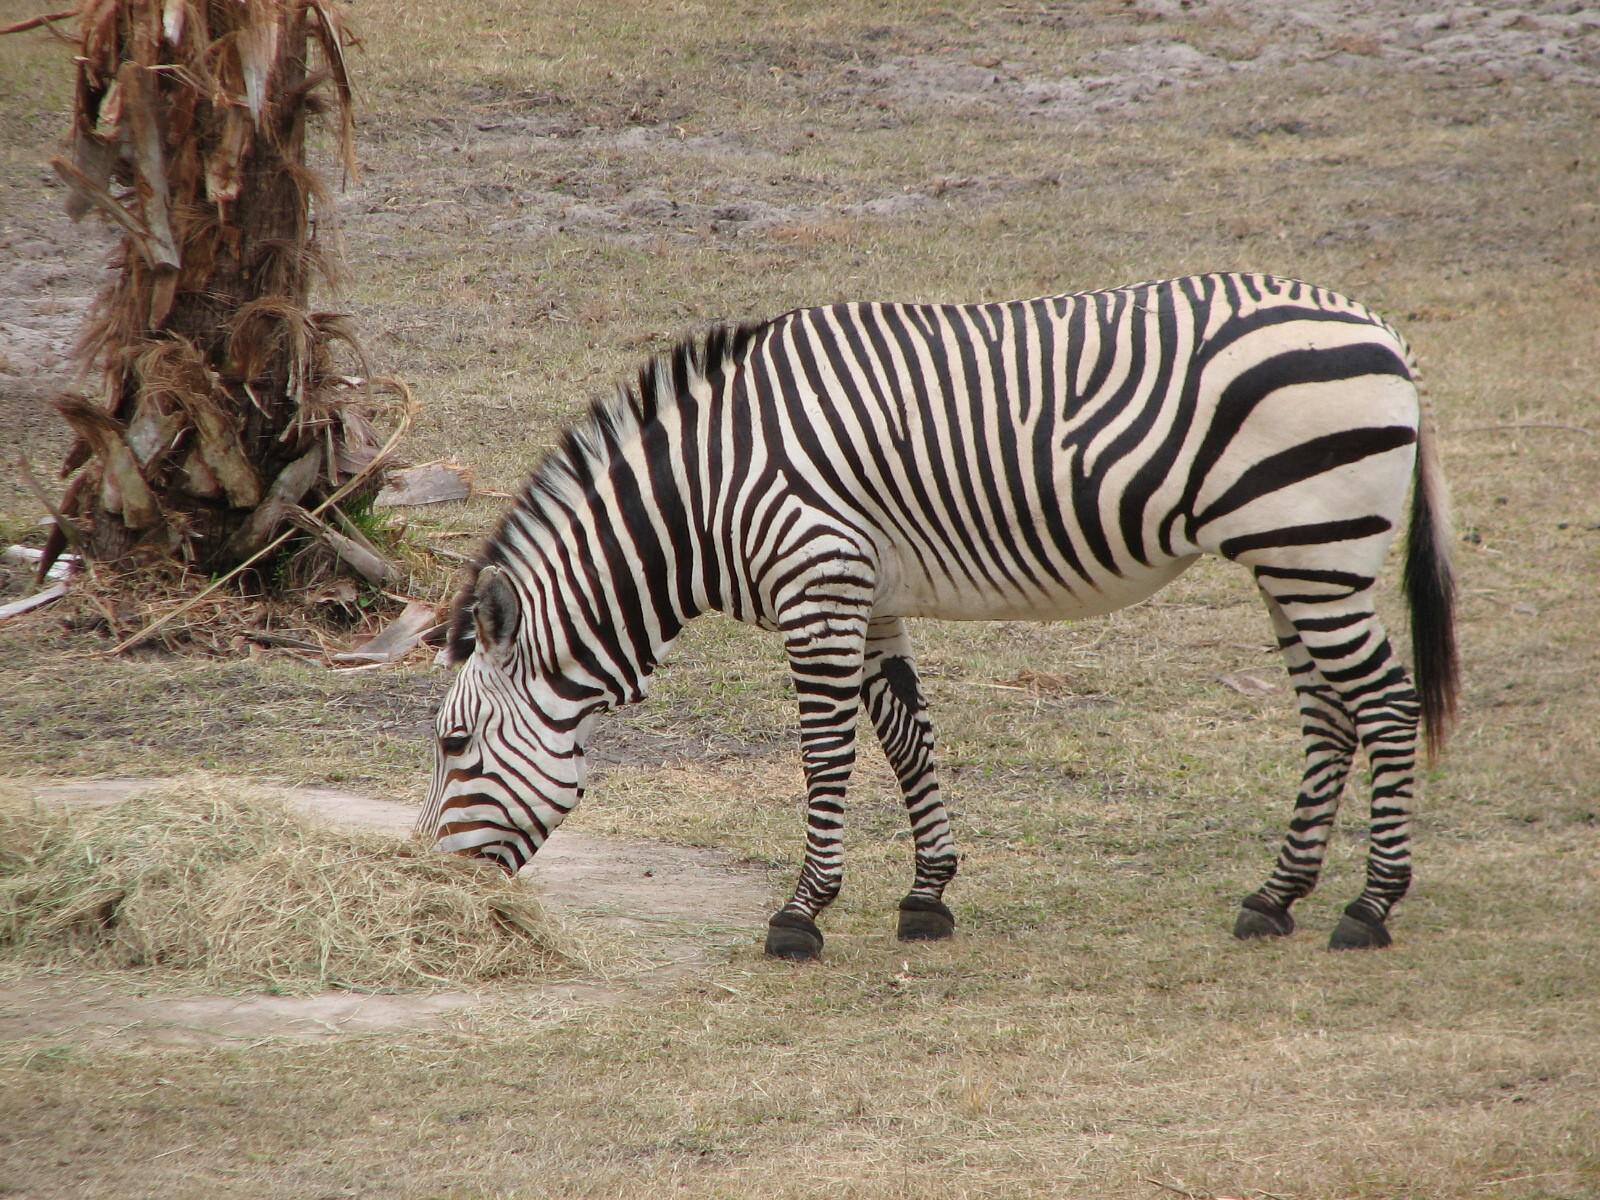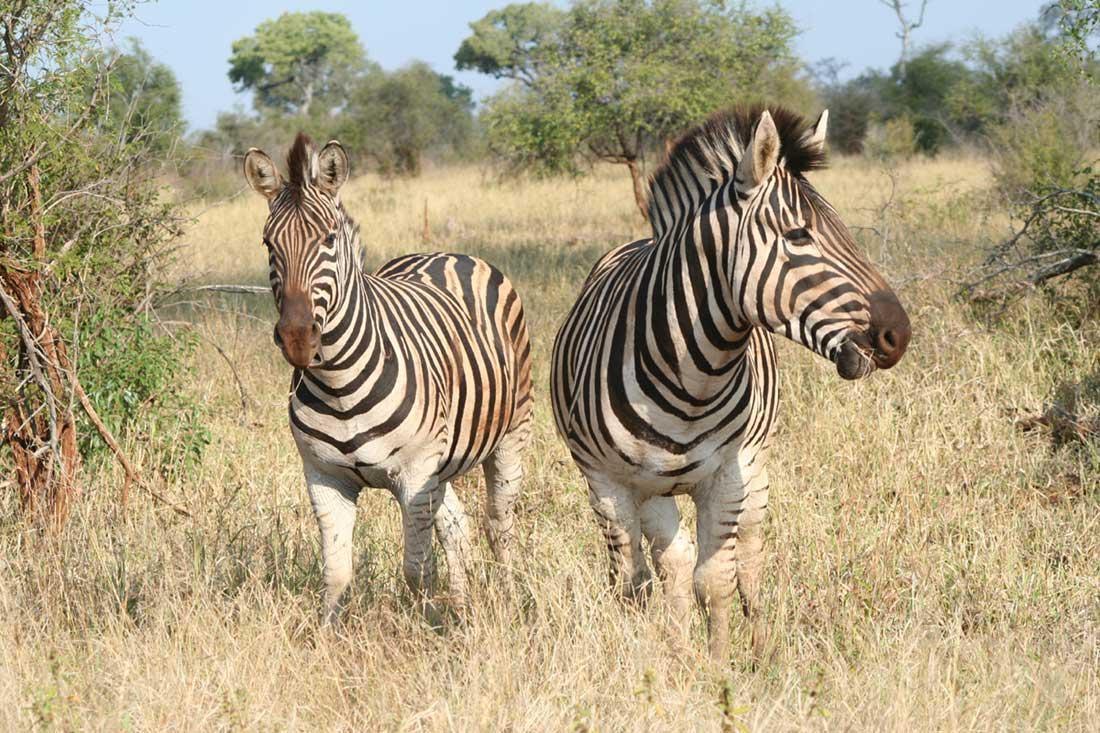The first image is the image on the left, the second image is the image on the right. Assess this claim about the two images: "There are two zebras in the left image.". Correct or not? Answer yes or no. No. The first image is the image on the left, the second image is the image on the right. For the images displayed, is the sentence "One of the images shows exactly one zebra, while the other image shows exactly two which have a brown tint to their coloring." factually correct? Answer yes or no. Yes. 